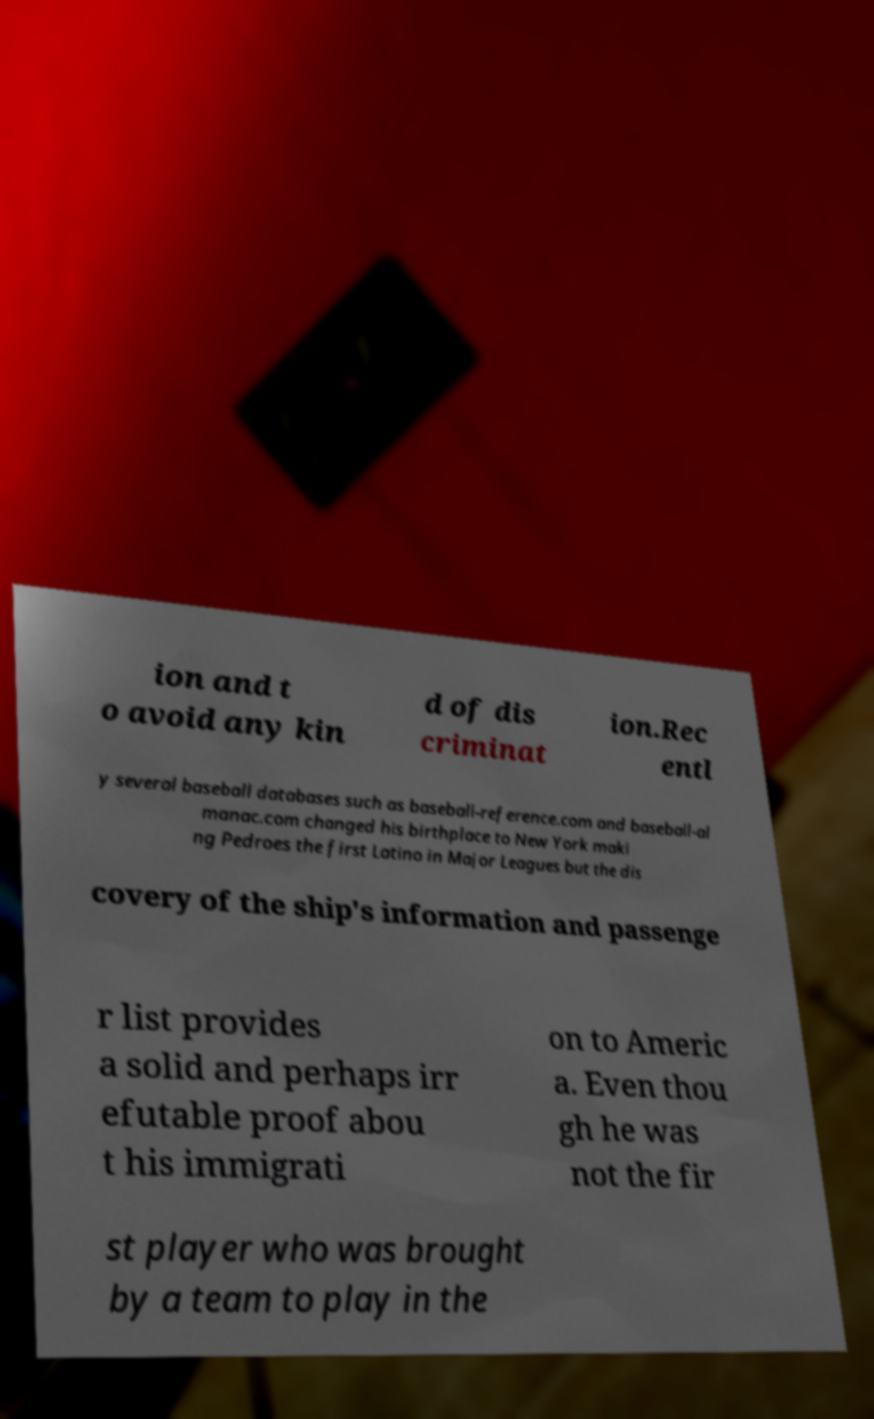Please identify and transcribe the text found in this image. ion and t o avoid any kin d of dis criminat ion.Rec entl y several baseball databases such as baseball-reference.com and baseball-al manac.com changed his birthplace to New York maki ng Pedroes the first Latino in Major Leagues but the dis covery of the ship's information and passenge r list provides a solid and perhaps irr efutable proof abou t his immigrati on to Americ a. Even thou gh he was not the fir st player who was brought by a team to play in the 